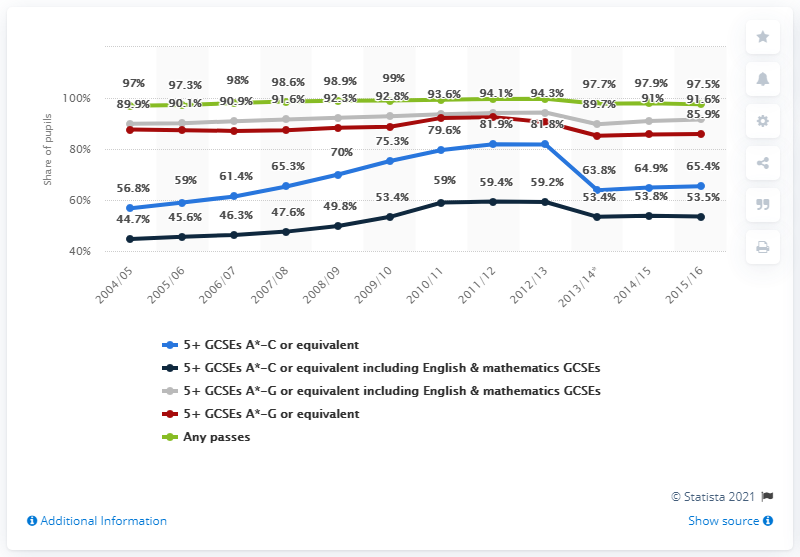Point out several critical features in this image. The peak for GCSE results was in the academic year 2011/12. 